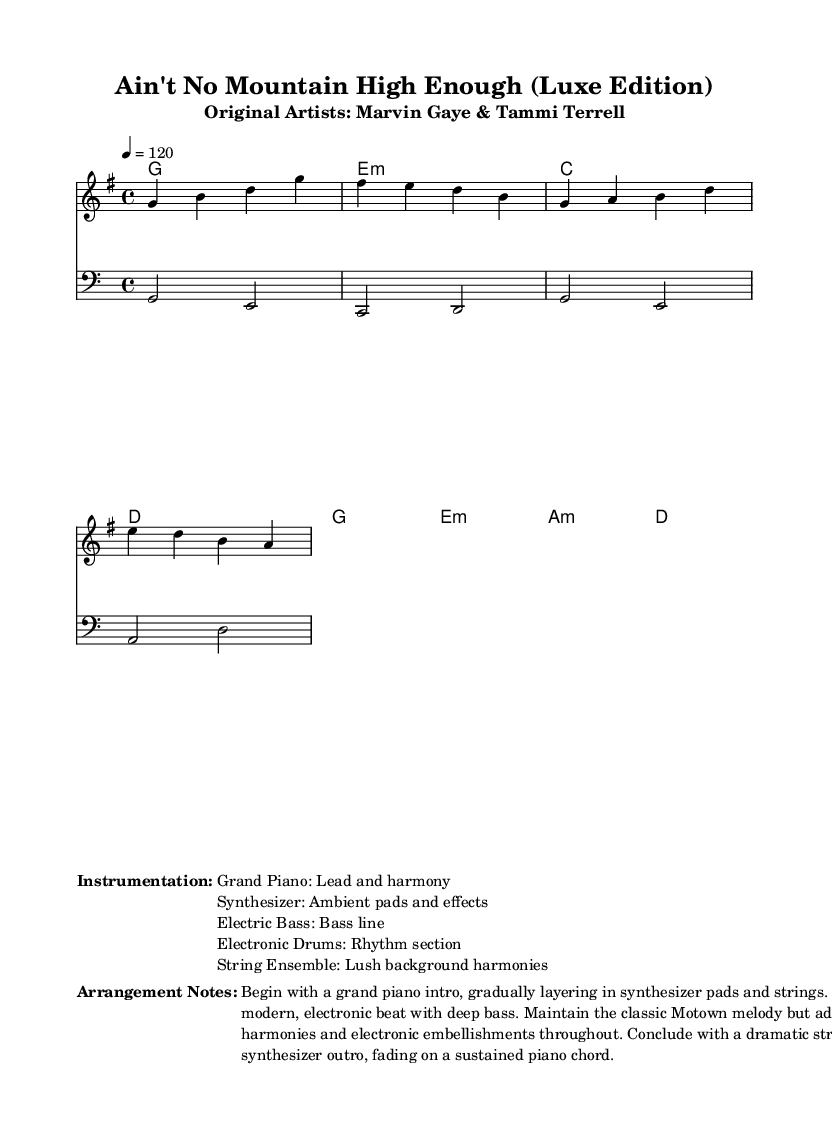What is the key signature of this music? The key signature is G major, which has one sharp (F#). You can identify the key signature by looking at the key signature section at the beginning of the staff where the sharp is indicated.
Answer: G major What is the time signature of this piece? The time signature is 4/4, which means there are four beats in each measure. This is indicated in the beginning of the score where the time signature is specifically noted.
Answer: 4/4 What is the tempo marking? The tempo marking is 120 beats per minute, which indicates the speed at which the piece should be played. This is indicated at the beginning where the tempo is specified.
Answer: 120 What instruments are used in this arrangement? The instruments mentioned are Grand Piano, Synthesizer, Electric Bass, Electronic Drums, and String Ensemble. You can find this listed in the markup section under "Instrumentation."
Answer: Grand Piano, Synthesizer, Electric Bass, Electronic Drums, String Ensemble How many measures are in the melody? The melody consists of 8 measures, which can be counted in the exposed score section where the melody is laid out. Each measure is separated by vertical lines, making it easy to count.
Answer: 8 What is the main characteristic of the arrangement? The main characteristic is a blending of classic Motown melody with modern production elements such as electronic beats and lush harmonies. This is outlined in the "Arrangement Notes," emphasizing the reimagined aspect of the song.
Answer: Blending classic Motown melody with modern production 